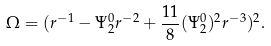Convert formula to latex. <formula><loc_0><loc_0><loc_500><loc_500>\Omega = ( r ^ { - 1 } - \Psi _ { 2 } ^ { 0 } r ^ { - 2 } + \frac { 1 1 } { 8 } ( \Psi _ { 2 } ^ { 0 } ) ^ { 2 } r ^ { - 3 } ) ^ { 2 } .</formula> 